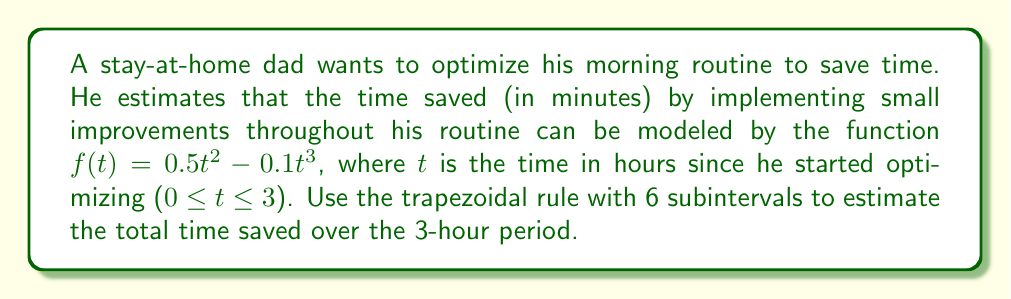What is the answer to this math problem? 1) The trapezoidal rule for numerical integration is given by:

   $$\int_a^b f(x)dx \approx \frac{h}{2}\left[f(x_0) + 2\sum_{i=1}^{n-1}f(x_i) + f(x_n)\right]$$

   where $h = \frac{b-a}{n}$, $n$ is the number of subintervals, and $x_i = a + ih$.

2) In this case, $a=0$, $b=3$, and $n=6$. So, $h = \frac{3-0}{6} = 0.5$.

3) Calculate the $x_i$ values:
   $x_0 = 0$, $x_1 = 0.5$, $x_2 = 1$, $x_3 = 1.5$, $x_4 = 2$, $x_5 = 2.5$, $x_6 = 3$

4) Calculate $f(x_i)$ for each $x_i$:
   $f(0) = 0$
   $f(0.5) = 0.5(0.5)^2 - 0.1(0.5)^3 = 0.11875$
   $f(1) = 0.5(1)^2 - 0.1(1)^3 = 0.4$
   $f(1.5) = 0.5(1.5)^2 - 0.1(1.5)^3 = 0.73125$
   $f(2) = 0.5(2)^2 - 0.1(2)^3 = 1$
   $f(2.5) = 0.5(2.5)^2 - 0.1(2.5)^3 = 1.09375$
   $f(3) = 0.5(3)^2 - 0.1(3)^3 = 0.9$

5) Apply the trapezoidal rule:

   $$\begin{align*}
   \text{Time saved} &\approx \frac{0.5}{2}[f(0) + 2(f(0.5) + f(1) + f(1.5) + f(2) + f(2.5)) + f(3)] \\
   &= 0.25[0 + 2(0.11875 + 0.4 + 0.73125 + 1 + 1.09375) + 0.9] \\
   &= 0.25[0 + 2(3.34375) + 0.9] \\
   &= 0.25[7.5875] \\
   &= 1.896875 \text{ minutes}
   \end{align*}$$
Answer: 1.90 minutes 